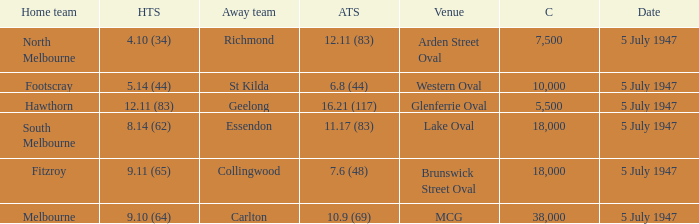Where was the game played where the away team has a score of 7.6 (48)? Brunswick Street Oval. 